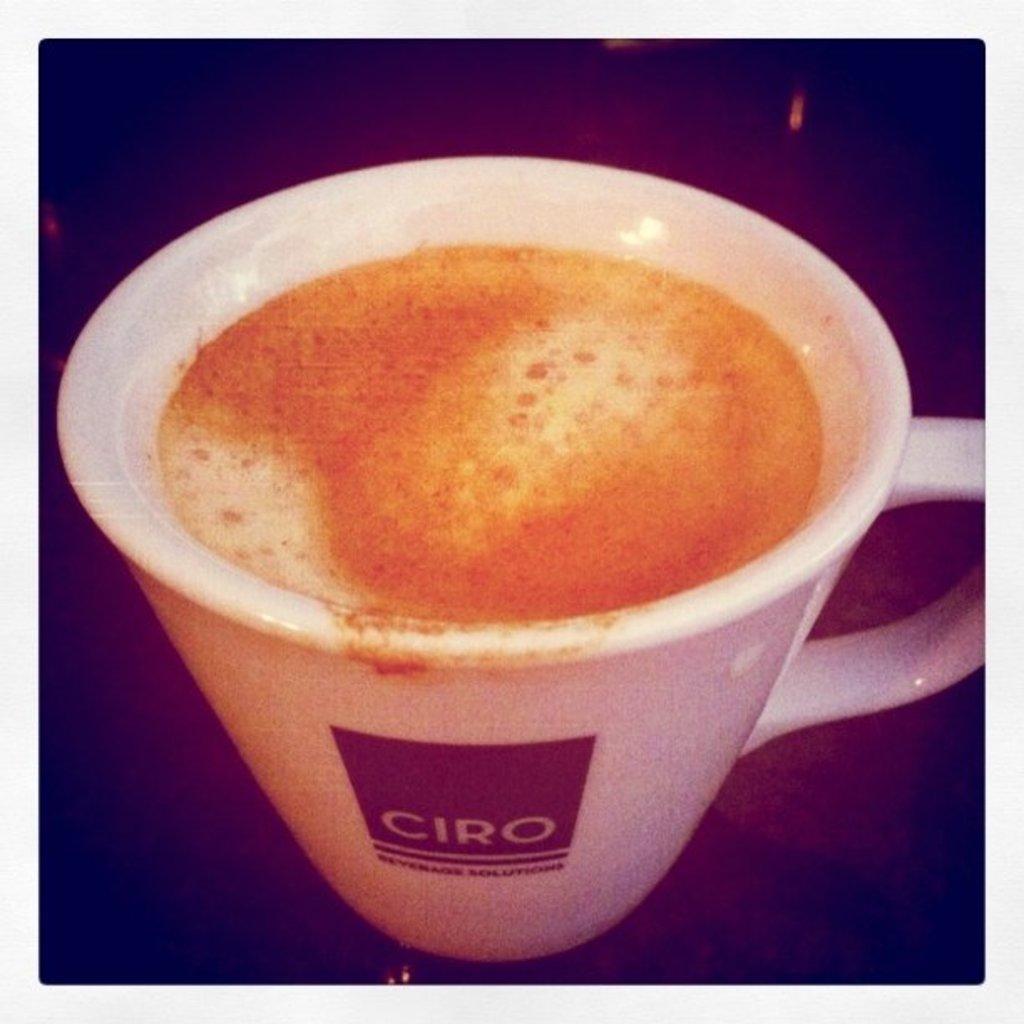Can you describe this image briefly? In this picture I can see the coffee in a cup, which is kept on the table. In the bottom left corner I can see the darkness. 